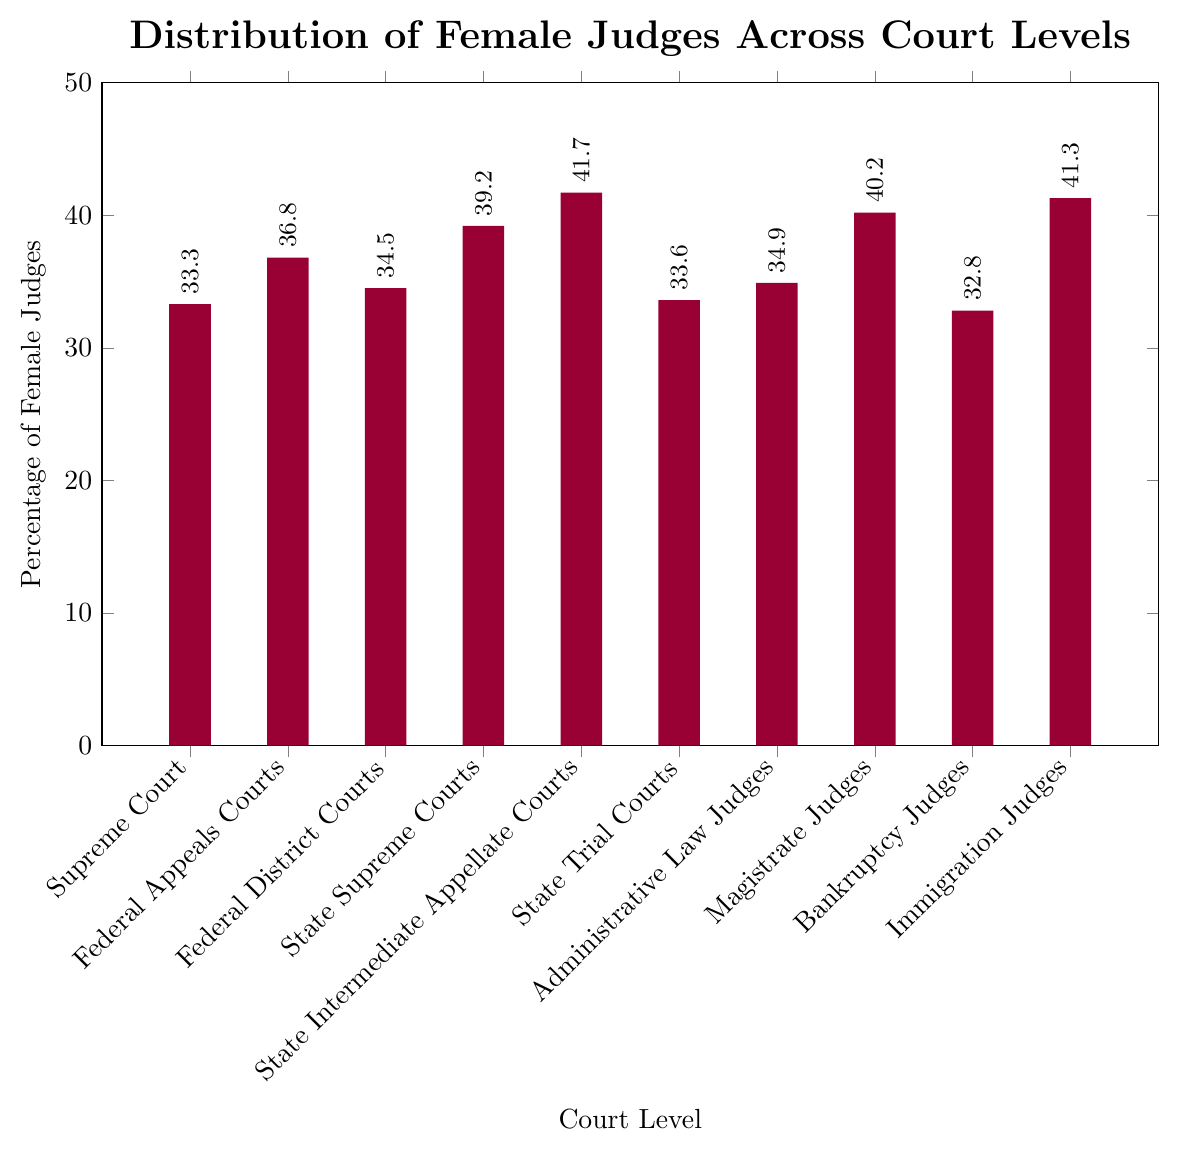What is the court level with the highest percentage of female judges? The court level with the highest percentage of female judges can be identified by finding the tallest bar in the chart. The tallest bar corresponds to the "State Intermediate Appellate Courts."
Answer: State Intermediate Appellate Courts Which two court levels have the smallest difference in the percentage of female judges? We need to find pairs of court levels that have a close percentage of female judges. By comparing the values, the closest are "Federal District Courts" (34.5%) and "Administrative Law Judges" (34.9%), with a difference of 0.4%.
Answer: Federal District Courts and Administrative Law Judges What is the average percentage of female judges across all court levels? To find the average percentage, sum up all the percentages and then divide by the number of court levels. The sum of percentages is (33.3 + 36.8 + 34.5 + 39.2 + 41.7 + 33.6 + 34.9 + 40.2 + 32.8 + 41.3) = 368.3. The number of court levels is 10. So, average is 368.3 / 10 = 36.83.
Answer: 36.83 Which court levels have a percentage of female judges greater than 40%? We identify the court levels with bars that reach above the 40% mark. The court levels are "State Intermediate Appellate Courts" (41.7%), "Magistrate Judges" (40.2%), and "Immigration Judges" (41.3%).
Answer: State Intermediate Appellate Courts, Magistrate Judges, Immigration Judges What is the range of the percentage of female judges across different court levels? The range is determined by subtracting the smallest percentage from the largest percentage. The smallest percentage is 32.8% (Bankruptcy Judges) and the largest is 41.7% (State Intermediate Appellate Courts). So, the range is 41.7 - 32.8 = 8.9.
Answer: 8.9 Compare the percentage of female judges in Federal Appeals Courts to State Supreme Courts. Which is higher and by how much? Federal Appeals Courts have 36.8%, and State Supreme Courts have 39.2%. The difference is 39.2 - 36.8 = 2.4, and State Supreme Courts have a higher percentage.
Answer: State Supreme Courts, by 2.4 Is the percentage of female judges in Federal District Courts closer to the percentage in Supreme Court or State Trial Courts? Federal District Courts have 34.5%. Supreme Court has 33.3%, and State Trial Courts have 33.6%. The difference with Supreme Court is 34.5 - 33.3 = 1.2, and with State Trial Courts is 34.5 - 33.6 = 0.9. The percentage is closer to State Trial Courts.
Answer: State Trial Courts 